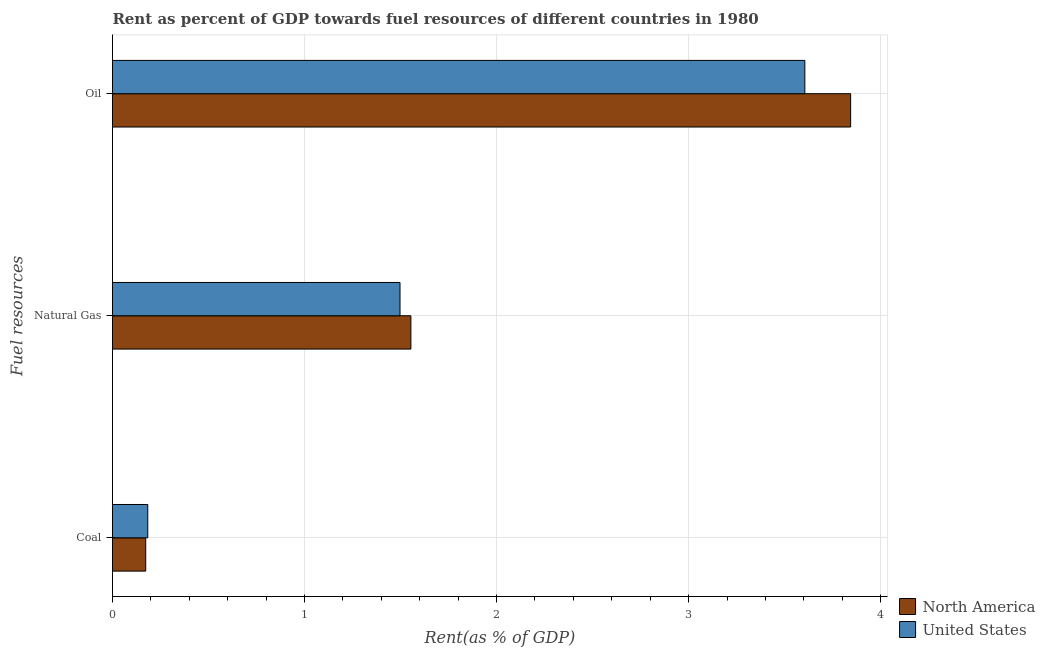How many different coloured bars are there?
Ensure brevity in your answer.  2. How many groups of bars are there?
Give a very brief answer. 3. How many bars are there on the 1st tick from the bottom?
Your answer should be very brief. 2. What is the label of the 1st group of bars from the top?
Provide a succinct answer. Oil. What is the rent towards natural gas in North America?
Give a very brief answer. 1.55. Across all countries, what is the maximum rent towards coal?
Make the answer very short. 0.18. Across all countries, what is the minimum rent towards coal?
Provide a short and direct response. 0.17. In which country was the rent towards coal maximum?
Your response must be concise. United States. What is the total rent towards oil in the graph?
Keep it short and to the point. 7.45. What is the difference between the rent towards natural gas in North America and that in United States?
Ensure brevity in your answer.  0.06. What is the difference between the rent towards oil in North America and the rent towards coal in United States?
Your response must be concise. 3.66. What is the average rent towards oil per country?
Ensure brevity in your answer.  3.72. What is the difference between the rent towards coal and rent towards natural gas in United States?
Offer a very short reply. -1.31. What is the ratio of the rent towards oil in North America to that in United States?
Your answer should be very brief. 1.07. Is the rent towards oil in North America less than that in United States?
Offer a very short reply. No. What is the difference between the highest and the second highest rent towards coal?
Your answer should be compact. 0.01. What is the difference between the highest and the lowest rent towards oil?
Your answer should be very brief. 0.24. In how many countries, is the rent towards natural gas greater than the average rent towards natural gas taken over all countries?
Your response must be concise. 1. What does the 1st bar from the top in Oil represents?
Your response must be concise. United States. What does the 1st bar from the bottom in Oil represents?
Your answer should be very brief. North America. Is it the case that in every country, the sum of the rent towards coal and rent towards natural gas is greater than the rent towards oil?
Your answer should be very brief. No. How many countries are there in the graph?
Your response must be concise. 2. What is the difference between two consecutive major ticks on the X-axis?
Offer a very short reply. 1. Does the graph contain any zero values?
Provide a short and direct response. No. How many legend labels are there?
Provide a succinct answer. 2. What is the title of the graph?
Keep it short and to the point. Rent as percent of GDP towards fuel resources of different countries in 1980. What is the label or title of the X-axis?
Ensure brevity in your answer.  Rent(as % of GDP). What is the label or title of the Y-axis?
Your answer should be compact. Fuel resources. What is the Rent(as % of GDP) in North America in Coal?
Offer a terse response. 0.17. What is the Rent(as % of GDP) of United States in Coal?
Offer a very short reply. 0.18. What is the Rent(as % of GDP) in North America in Natural Gas?
Your answer should be very brief. 1.55. What is the Rent(as % of GDP) in United States in Natural Gas?
Offer a terse response. 1.5. What is the Rent(as % of GDP) in North America in Oil?
Keep it short and to the point. 3.84. What is the Rent(as % of GDP) in United States in Oil?
Give a very brief answer. 3.61. Across all Fuel resources, what is the maximum Rent(as % of GDP) in North America?
Keep it short and to the point. 3.84. Across all Fuel resources, what is the maximum Rent(as % of GDP) in United States?
Your response must be concise. 3.61. Across all Fuel resources, what is the minimum Rent(as % of GDP) of North America?
Your answer should be compact. 0.17. Across all Fuel resources, what is the minimum Rent(as % of GDP) in United States?
Keep it short and to the point. 0.18. What is the total Rent(as % of GDP) in North America in the graph?
Provide a short and direct response. 5.57. What is the total Rent(as % of GDP) of United States in the graph?
Your response must be concise. 5.29. What is the difference between the Rent(as % of GDP) in North America in Coal and that in Natural Gas?
Ensure brevity in your answer.  -1.38. What is the difference between the Rent(as % of GDP) of United States in Coal and that in Natural Gas?
Make the answer very short. -1.31. What is the difference between the Rent(as % of GDP) of North America in Coal and that in Oil?
Make the answer very short. -3.67. What is the difference between the Rent(as % of GDP) of United States in Coal and that in Oil?
Keep it short and to the point. -3.42. What is the difference between the Rent(as % of GDP) in North America in Natural Gas and that in Oil?
Your response must be concise. -2.29. What is the difference between the Rent(as % of GDP) in United States in Natural Gas and that in Oil?
Your response must be concise. -2.11. What is the difference between the Rent(as % of GDP) of North America in Coal and the Rent(as % of GDP) of United States in Natural Gas?
Ensure brevity in your answer.  -1.32. What is the difference between the Rent(as % of GDP) in North America in Coal and the Rent(as % of GDP) in United States in Oil?
Your answer should be compact. -3.43. What is the difference between the Rent(as % of GDP) in North America in Natural Gas and the Rent(as % of GDP) in United States in Oil?
Offer a very short reply. -2.05. What is the average Rent(as % of GDP) of North America per Fuel resources?
Your answer should be very brief. 1.86. What is the average Rent(as % of GDP) in United States per Fuel resources?
Give a very brief answer. 1.76. What is the difference between the Rent(as % of GDP) of North America and Rent(as % of GDP) of United States in Coal?
Offer a very short reply. -0.01. What is the difference between the Rent(as % of GDP) in North America and Rent(as % of GDP) in United States in Natural Gas?
Your answer should be compact. 0.06. What is the difference between the Rent(as % of GDP) of North America and Rent(as % of GDP) of United States in Oil?
Your answer should be compact. 0.24. What is the ratio of the Rent(as % of GDP) of North America in Coal to that in Natural Gas?
Offer a terse response. 0.11. What is the ratio of the Rent(as % of GDP) in United States in Coal to that in Natural Gas?
Provide a succinct answer. 0.12. What is the ratio of the Rent(as % of GDP) in North America in Coal to that in Oil?
Your answer should be very brief. 0.04. What is the ratio of the Rent(as % of GDP) in United States in Coal to that in Oil?
Offer a very short reply. 0.05. What is the ratio of the Rent(as % of GDP) in North America in Natural Gas to that in Oil?
Make the answer very short. 0.4. What is the ratio of the Rent(as % of GDP) of United States in Natural Gas to that in Oil?
Your response must be concise. 0.42. What is the difference between the highest and the second highest Rent(as % of GDP) in North America?
Provide a short and direct response. 2.29. What is the difference between the highest and the second highest Rent(as % of GDP) in United States?
Your answer should be very brief. 2.11. What is the difference between the highest and the lowest Rent(as % of GDP) of North America?
Provide a short and direct response. 3.67. What is the difference between the highest and the lowest Rent(as % of GDP) in United States?
Your answer should be compact. 3.42. 